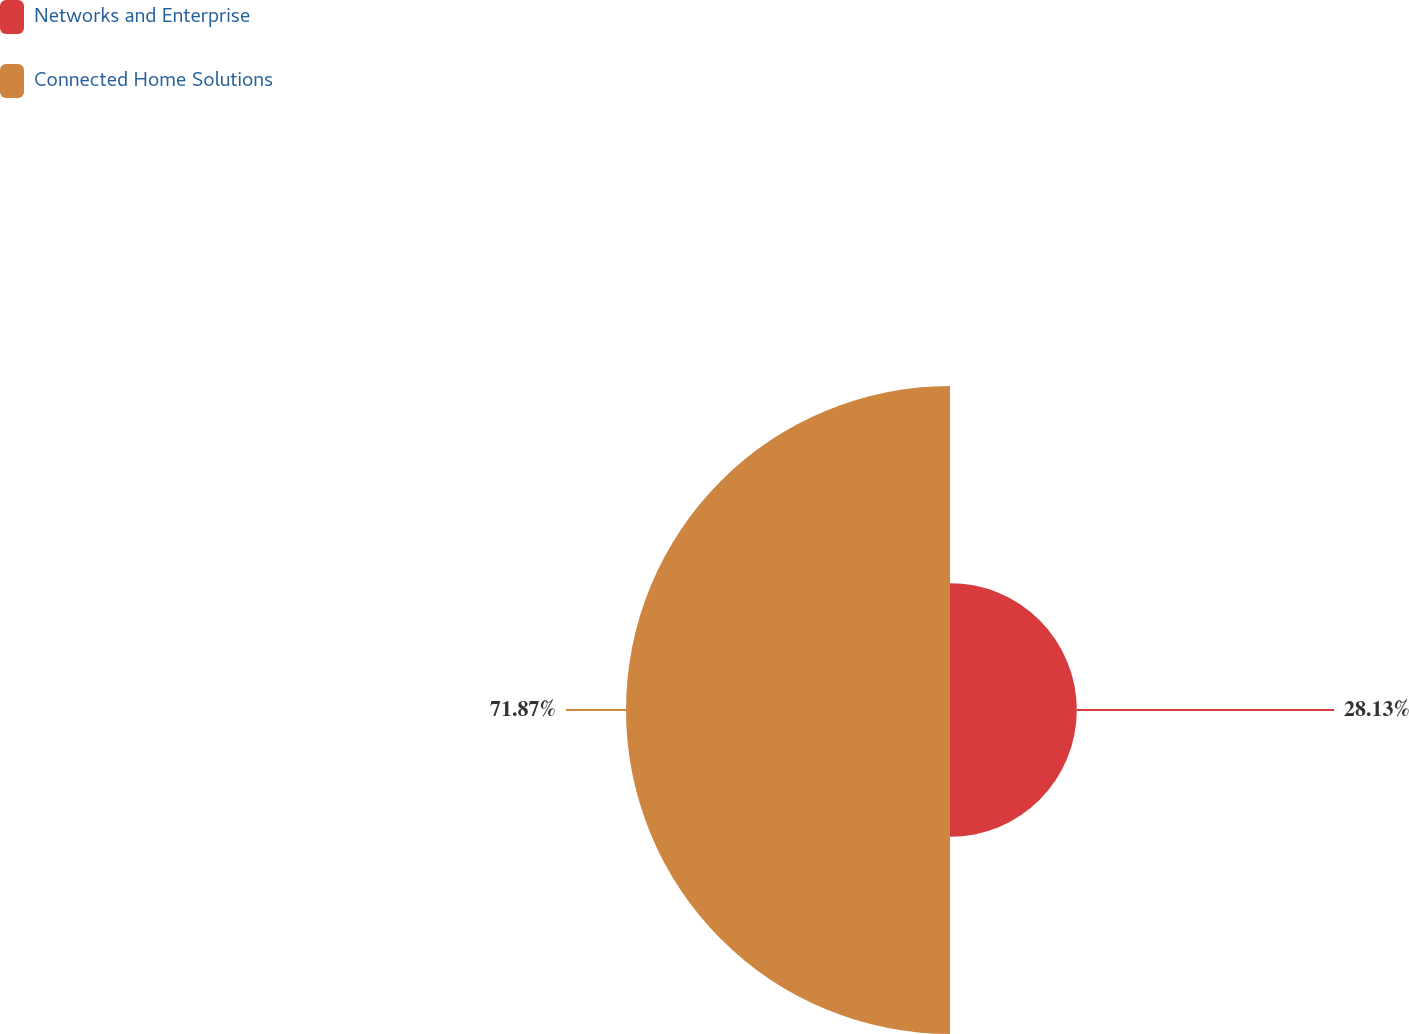Convert chart. <chart><loc_0><loc_0><loc_500><loc_500><pie_chart><fcel>Networks and Enterprise<fcel>Connected Home Solutions<nl><fcel>28.13%<fcel>71.87%<nl></chart> 